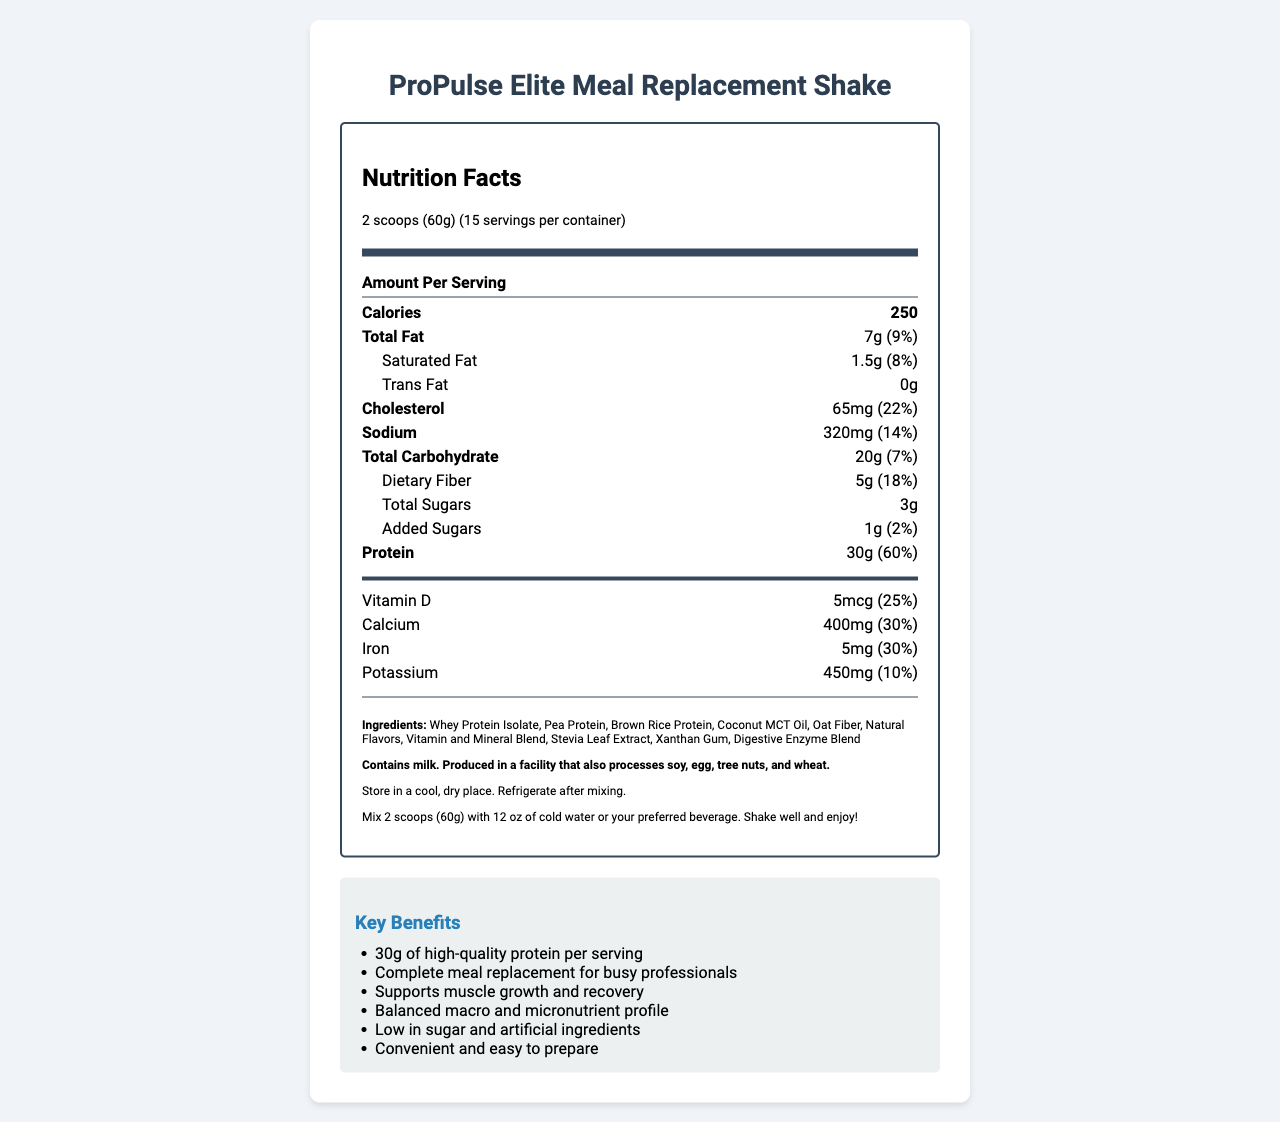what is the serving size of ProPulse Elite Meal Replacement Shake? The serving size is mentioned at the top of the nutrition label as "2 scoops (60g)".
Answer: 2 scoops (60g) How many servings are there per container? The document states there are 15 servings per container.
Answer: 15 What is the total calorie count per serving? The total calorie count per serving is clearly stated as 250 on the label.
Answer: 250 Identify the total amount of protein per serving and its daily value percentage. The protein content is mentioned as 30g with a 60% daily value.
Answer: 30g, 60% What vitamins have a daily value percentage of 50%? All these vitamins and minerals are marked with a daily value percentage of 50% on the label.
Answer: Vitamin A, Vitamin C, Vitamin E, Vitamin K, Thiamin, Riboflavin, Niacin, Vitamin B6, Folate, Vitamin B12, Biotin, Pantothenic Acid, Iodine, Zinc, Selenium, Copper, Manganese, Chromium, Molybdenum Which nutrient has the highest daily value percentage? A. Total Fat B. Cholesterol C. Sodium D. Protein Protein has a daily value of 60%, which is the highest among the options.
Answer: D. Protein How much calcium does one serving contain? A. 100mg B. 200mg C. 400mg D. 500mg Calcium content is listed as 400mg per serving.
Answer: C. 400mg Does ProPulse Elite Meal Replacement Shake contain any allergens? The label mentions that it contains milk and is produced in a facility that processes soy, egg, tree nuts, and wheat.
Answer: Yes Summarize the key benefits and target audience of ProPulse Elite Meal Replacement Shake. The summary includes key benefits like supporting muscle growth, being low in sugar, and convenience. It also mentions that the target audience is busy professionals.
Answer: ProPulse Elite Meal Replacement Shake is designed for busy professionals who need a nutritious meal replacement. It supports muscle growth and recovery, has a balanced macro and micronutrient profile, is low in sugar and artificial ingredients, and is convenient and easy to prepare. What is the flavor of the ProPulse Elite Meal Replacement Shake? The flavor is clearly stated as Vanilla Bean on the label.
Answer: Vanilla Bean Is this product certified as Non-GMO? The label includes Non-GMO as one of the certifications.
Answer: Yes What is the storage instruction after mixing the shake? One of the storage instructions on the label is to refrigerate after mixing.
Answer: Refrigerate after mixing. What are the preparation instructions for the shake? The preparation instructions are provided on the label, specifying the amount of powder and liquid to use.
Answer: Mix 2 scoops (60g) with 12 oz of cold water or your preferred beverage. Shake well and enjoy! Who should not use this product based on the allergen information? The allergen information states that it contains milk and is produced in a facility that also processes soy, egg, tree nuts, and wheat. However, it does not specifically say who should avoid using the product.
Answer: Cannot be determined 